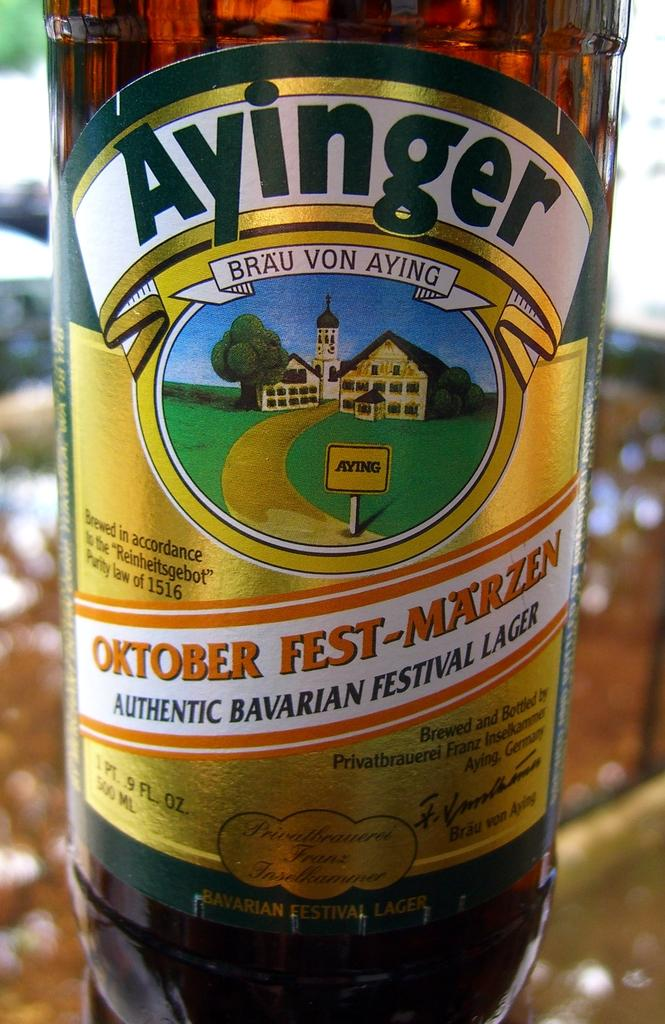Provide a one-sentence caption for the provided image. A bottle of Ayinger Oktober Fest-Marzen Authentic Bavarian Festival Lager. 